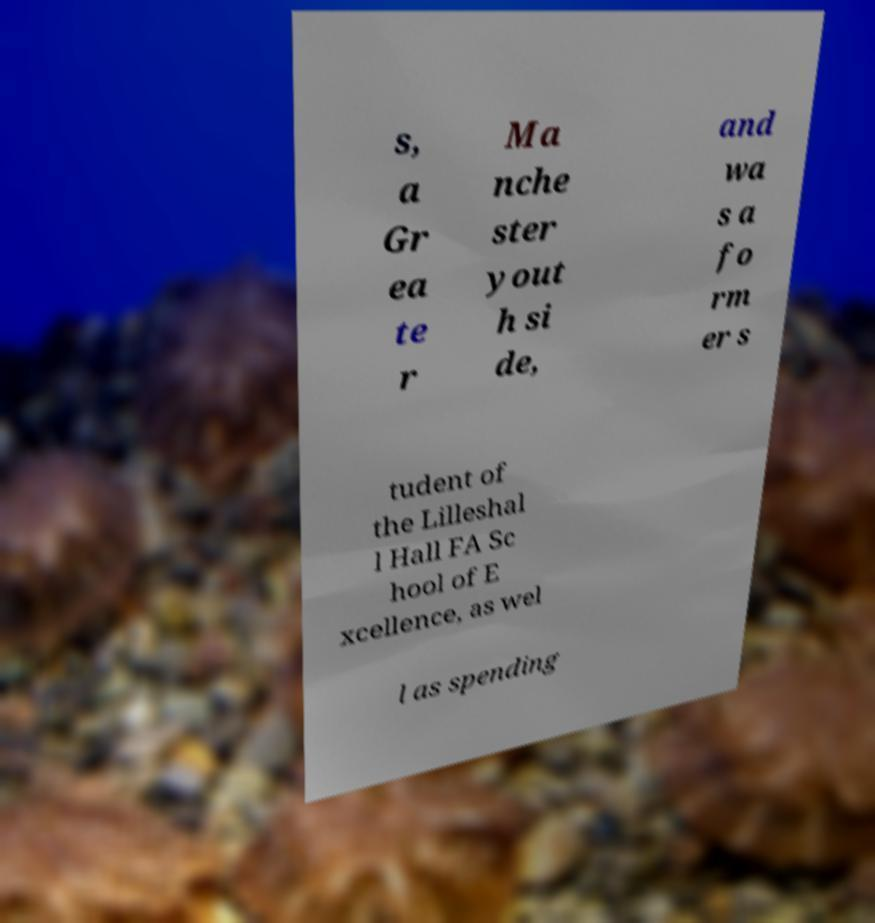Can you read and provide the text displayed in the image?This photo seems to have some interesting text. Can you extract and type it out for me? s, a Gr ea te r Ma nche ster yout h si de, and wa s a fo rm er s tudent of the Lilleshal l Hall FA Sc hool of E xcellence, as wel l as spending 